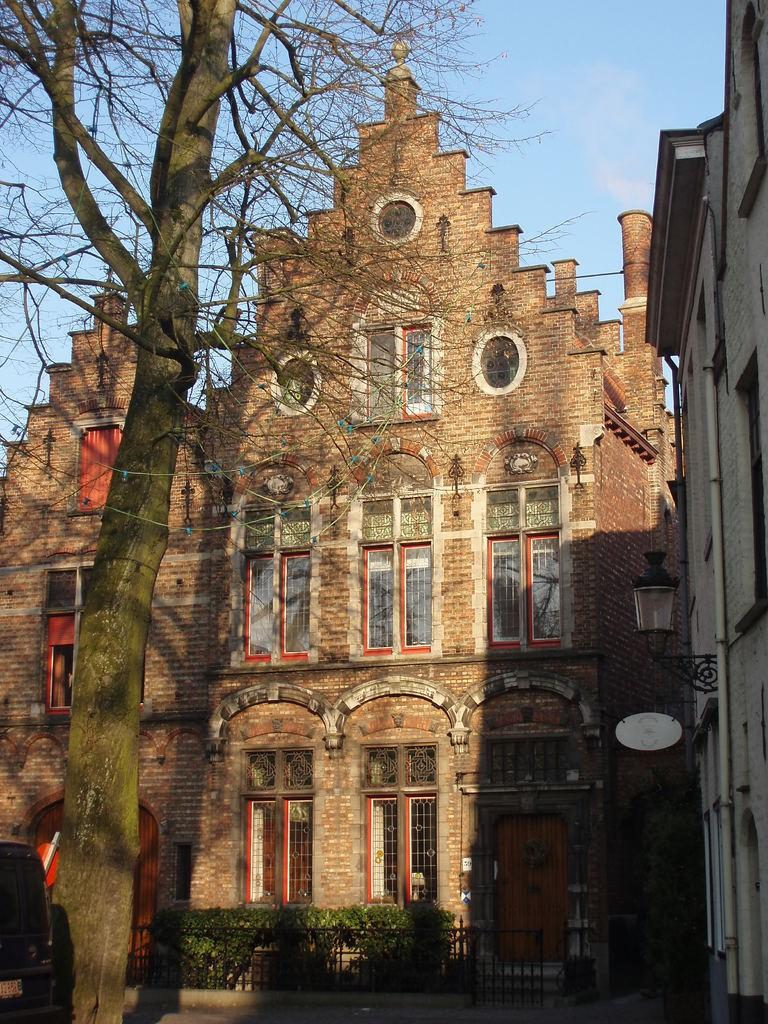What type of natural element can be seen in the image? There is a tree in the image. What type of man-made structures are visible in the background? There are buildings in the background of the image. What other natural elements can be seen in the background? There are plants in the background of the image. What part of the natural environment is visible in the background? The sky is visible in the background of the image. What type of legal advice can be seen in the image? There is no legal advice present in the image; it features a tree, buildings, plants, and the sky. What type of financial instrument is visible in the image? There is no financial instrument present in the image; it features a tree, buildings, plants, and the sky. 